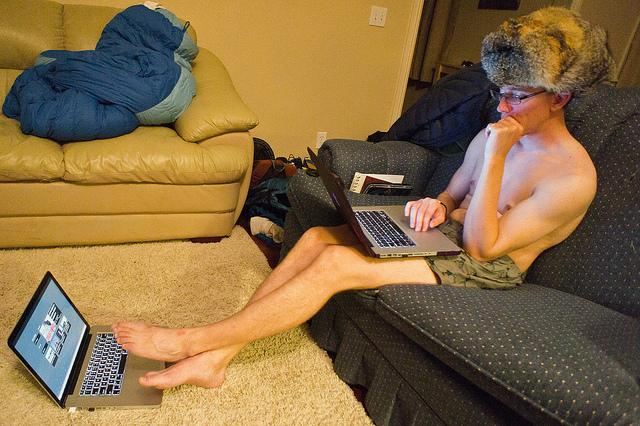What area of the computer is he touching with his fingers? keyboard 